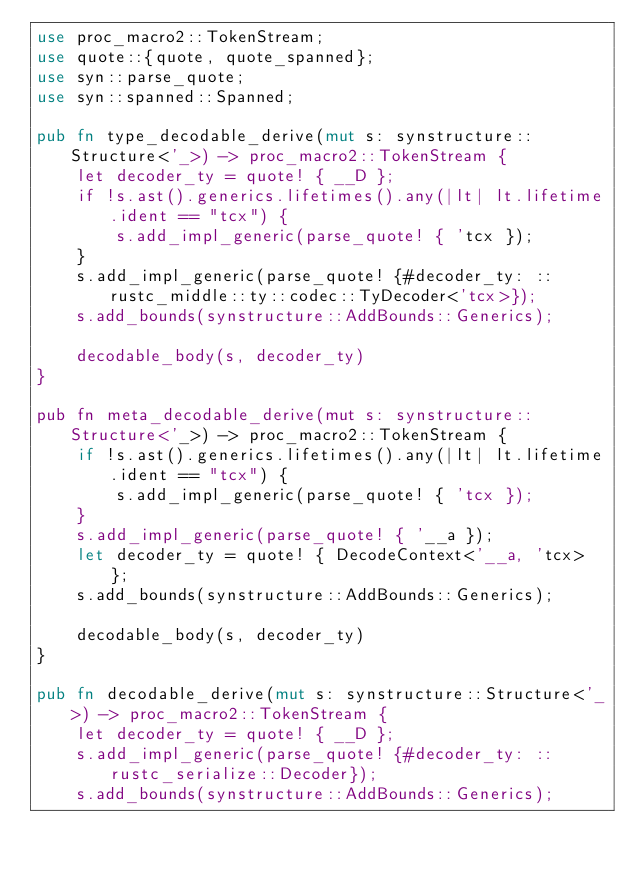<code> <loc_0><loc_0><loc_500><loc_500><_Rust_>use proc_macro2::TokenStream;
use quote::{quote, quote_spanned};
use syn::parse_quote;
use syn::spanned::Spanned;

pub fn type_decodable_derive(mut s: synstructure::Structure<'_>) -> proc_macro2::TokenStream {
    let decoder_ty = quote! { __D };
    if !s.ast().generics.lifetimes().any(|lt| lt.lifetime.ident == "tcx") {
        s.add_impl_generic(parse_quote! { 'tcx });
    }
    s.add_impl_generic(parse_quote! {#decoder_ty: ::rustc_middle::ty::codec::TyDecoder<'tcx>});
    s.add_bounds(synstructure::AddBounds::Generics);

    decodable_body(s, decoder_ty)
}

pub fn meta_decodable_derive(mut s: synstructure::Structure<'_>) -> proc_macro2::TokenStream {
    if !s.ast().generics.lifetimes().any(|lt| lt.lifetime.ident == "tcx") {
        s.add_impl_generic(parse_quote! { 'tcx });
    }
    s.add_impl_generic(parse_quote! { '__a });
    let decoder_ty = quote! { DecodeContext<'__a, 'tcx> };
    s.add_bounds(synstructure::AddBounds::Generics);

    decodable_body(s, decoder_ty)
}

pub fn decodable_derive(mut s: synstructure::Structure<'_>) -> proc_macro2::TokenStream {
    let decoder_ty = quote! { __D };
    s.add_impl_generic(parse_quote! {#decoder_ty: ::rustc_serialize::Decoder});
    s.add_bounds(synstructure::AddBounds::Generics);
</code> 